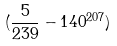<formula> <loc_0><loc_0><loc_500><loc_500>( \frac { 5 } { 2 3 9 } - 1 4 0 ^ { 2 0 7 } )</formula> 